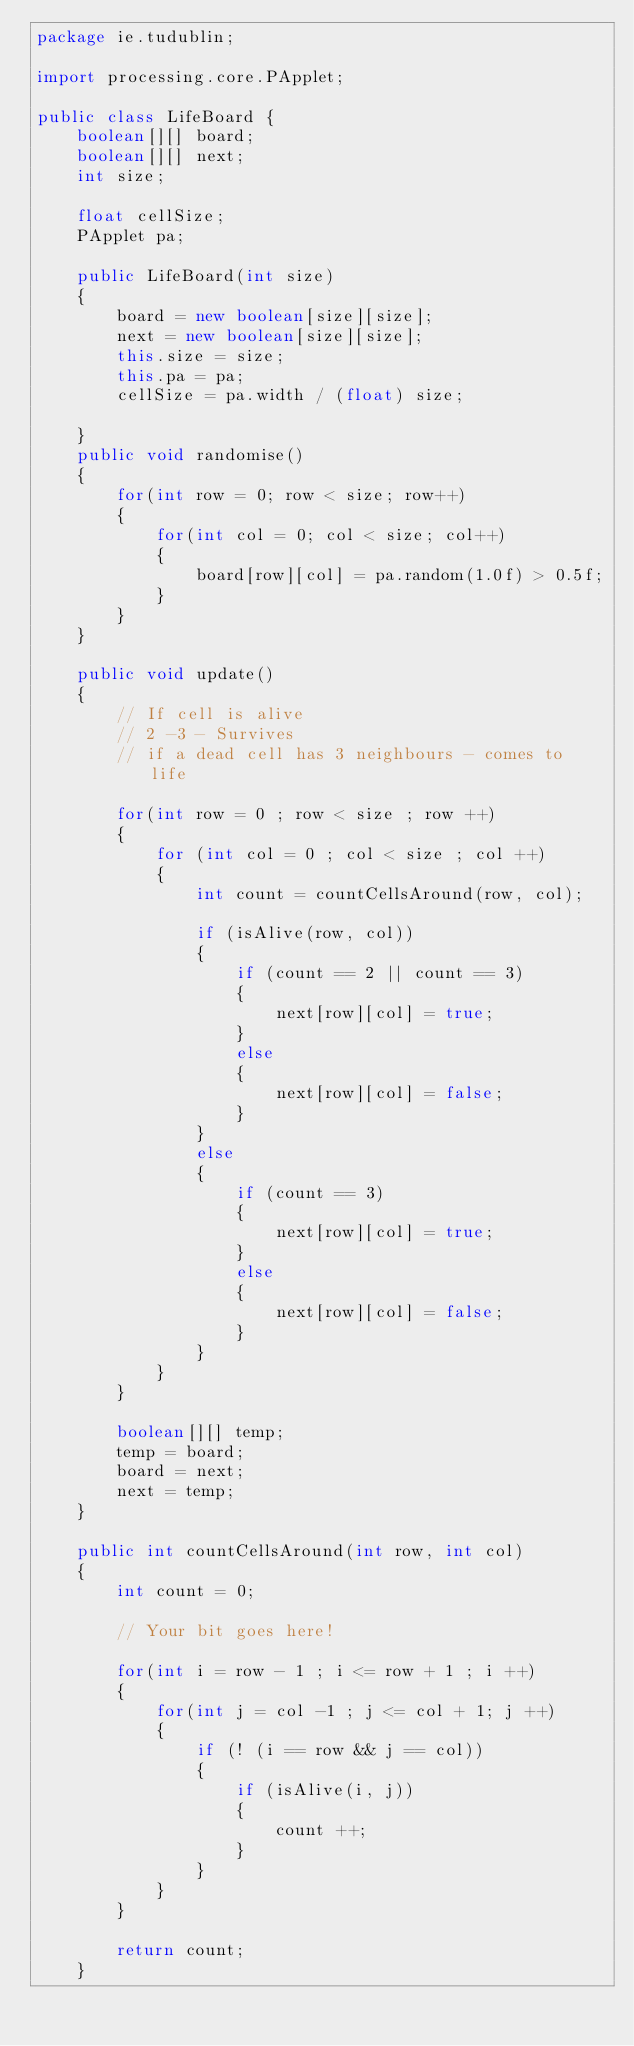<code> <loc_0><loc_0><loc_500><loc_500><_Java_>package ie.tudublin;

import processing.core.PApplet;

public class LifeBoard {
    boolean[][] board;
    boolean[][] next;
    int size;

    float cellSize;
    PApplet pa;

    public LifeBoard(int size)
    {
        board = new boolean[size][size];
        next = new boolean[size][size];
        this.size = size;
        this.pa = pa;
        cellSize = pa.width / (float) size;

    }
    public void randomise()
    {
        for(int row = 0; row < size; row++)
        {
            for(int col = 0; col < size; col++)
            {
                board[row][col] = pa.random(1.0f) > 0.5f;
            }
        }
    }

    public void update()
    {
        // If cell is alive
        // 2 -3 - Survives
        // if a dead cell has 3 neighbours - comes to life

        for(int row = 0 ; row < size ; row ++)
        {
            for (int col = 0 ; col < size ; col ++)
            {
                int count = countCellsAround(row, col);

                if (isAlive(row, col))
                {
                    if (count == 2 || count == 3)
                    {
                        next[row][col] = true;
                    }
                    else
                    {
                        next[row][col] = false;
                    }
                }
                else
                {
                    if (count == 3)
                    {
                        next[row][col] = true;
                    }
                    else
                    {
                        next[row][col] = false;
                    }
                }
            }
        }

        boolean[][] temp;
        temp = board;
        board = next;
        next = temp;
    }

    public int countCellsAround(int row, int col)
    {
        int count = 0;

        // Your bit goes here!

        for(int i = row - 1 ; i <= row + 1 ; i ++)
        {
            for(int j = col -1 ; j <= col + 1; j ++)
            {
                if (! (i == row && j == col))
                {
                    if (isAlive(i, j))
                    {
                        count ++;
                    }
                }
            }
        }

        return count;
    }
</code> 